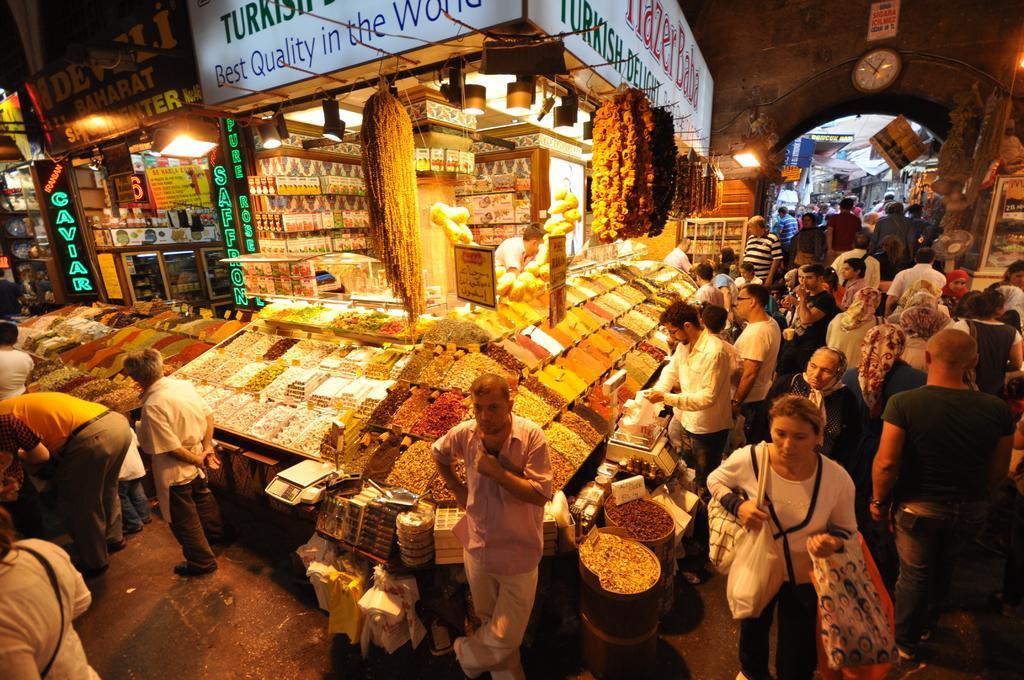Could you give a brief overview of what you see in this image? In this image I can see number of people are standing. I can also see number of stuffs in these boxes. In the background I can see few boards and on these words I can see something is written. Over there I can see a clock and few lights. 